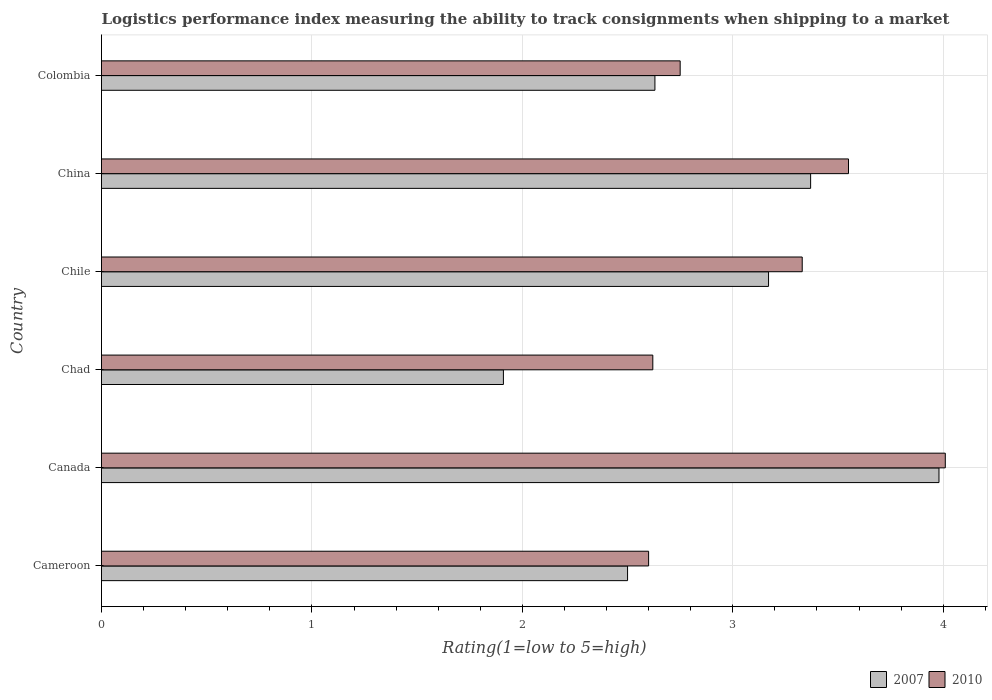How many groups of bars are there?
Your response must be concise. 6. Are the number of bars per tick equal to the number of legend labels?
Give a very brief answer. Yes. How many bars are there on the 5th tick from the top?
Offer a very short reply. 2. What is the label of the 6th group of bars from the top?
Provide a short and direct response. Cameroon. In how many cases, is the number of bars for a given country not equal to the number of legend labels?
Give a very brief answer. 0. What is the Logistic performance index in 2007 in Canada?
Keep it short and to the point. 3.98. Across all countries, what is the maximum Logistic performance index in 2007?
Offer a very short reply. 3.98. Across all countries, what is the minimum Logistic performance index in 2007?
Your answer should be very brief. 1.91. In which country was the Logistic performance index in 2007 maximum?
Provide a succinct answer. Canada. In which country was the Logistic performance index in 2007 minimum?
Ensure brevity in your answer.  Chad. What is the total Logistic performance index in 2007 in the graph?
Your answer should be compact. 17.56. What is the difference between the Logistic performance index in 2007 in Cameroon and that in Colombia?
Provide a succinct answer. -0.13. What is the difference between the Logistic performance index in 2010 in Chile and the Logistic performance index in 2007 in Colombia?
Your answer should be compact. 0.7. What is the average Logistic performance index in 2010 per country?
Offer a terse response. 3.14. What is the difference between the Logistic performance index in 2010 and Logistic performance index in 2007 in Chile?
Your answer should be compact. 0.16. In how many countries, is the Logistic performance index in 2007 greater than 2.8 ?
Offer a terse response. 3. What is the ratio of the Logistic performance index in 2010 in Cameroon to that in Chile?
Offer a terse response. 0.78. Is the Logistic performance index in 2010 in Cameroon less than that in Canada?
Give a very brief answer. Yes. What is the difference between the highest and the second highest Logistic performance index in 2010?
Provide a short and direct response. 0.46. What is the difference between the highest and the lowest Logistic performance index in 2010?
Offer a very short reply. 1.41. In how many countries, is the Logistic performance index in 2007 greater than the average Logistic performance index in 2007 taken over all countries?
Your answer should be very brief. 3. Are all the bars in the graph horizontal?
Provide a short and direct response. Yes. How many countries are there in the graph?
Keep it short and to the point. 6. Does the graph contain any zero values?
Your answer should be compact. No. What is the title of the graph?
Provide a short and direct response. Logistics performance index measuring the ability to track consignments when shipping to a market. Does "1977" appear as one of the legend labels in the graph?
Your answer should be compact. No. What is the label or title of the X-axis?
Keep it short and to the point. Rating(1=low to 5=high). What is the label or title of the Y-axis?
Ensure brevity in your answer.  Country. What is the Rating(1=low to 5=high) of 2007 in Cameroon?
Provide a short and direct response. 2.5. What is the Rating(1=low to 5=high) in 2007 in Canada?
Your answer should be compact. 3.98. What is the Rating(1=low to 5=high) in 2010 in Canada?
Provide a succinct answer. 4.01. What is the Rating(1=low to 5=high) of 2007 in Chad?
Provide a succinct answer. 1.91. What is the Rating(1=low to 5=high) of 2010 in Chad?
Offer a terse response. 2.62. What is the Rating(1=low to 5=high) of 2007 in Chile?
Your answer should be compact. 3.17. What is the Rating(1=low to 5=high) of 2010 in Chile?
Offer a very short reply. 3.33. What is the Rating(1=low to 5=high) of 2007 in China?
Ensure brevity in your answer.  3.37. What is the Rating(1=low to 5=high) of 2010 in China?
Your answer should be compact. 3.55. What is the Rating(1=low to 5=high) of 2007 in Colombia?
Make the answer very short. 2.63. What is the Rating(1=low to 5=high) in 2010 in Colombia?
Offer a terse response. 2.75. Across all countries, what is the maximum Rating(1=low to 5=high) in 2007?
Offer a very short reply. 3.98. Across all countries, what is the maximum Rating(1=low to 5=high) of 2010?
Offer a very short reply. 4.01. Across all countries, what is the minimum Rating(1=low to 5=high) of 2007?
Your answer should be very brief. 1.91. What is the total Rating(1=low to 5=high) in 2007 in the graph?
Keep it short and to the point. 17.56. What is the total Rating(1=low to 5=high) of 2010 in the graph?
Keep it short and to the point. 18.86. What is the difference between the Rating(1=low to 5=high) of 2007 in Cameroon and that in Canada?
Offer a terse response. -1.48. What is the difference between the Rating(1=low to 5=high) of 2010 in Cameroon and that in Canada?
Keep it short and to the point. -1.41. What is the difference between the Rating(1=low to 5=high) of 2007 in Cameroon and that in Chad?
Provide a short and direct response. 0.59. What is the difference between the Rating(1=low to 5=high) of 2010 in Cameroon and that in Chad?
Give a very brief answer. -0.02. What is the difference between the Rating(1=low to 5=high) in 2007 in Cameroon and that in Chile?
Keep it short and to the point. -0.67. What is the difference between the Rating(1=low to 5=high) in 2010 in Cameroon and that in Chile?
Offer a very short reply. -0.73. What is the difference between the Rating(1=low to 5=high) in 2007 in Cameroon and that in China?
Make the answer very short. -0.87. What is the difference between the Rating(1=low to 5=high) in 2010 in Cameroon and that in China?
Your answer should be compact. -0.95. What is the difference between the Rating(1=low to 5=high) of 2007 in Cameroon and that in Colombia?
Offer a terse response. -0.13. What is the difference between the Rating(1=low to 5=high) of 2010 in Cameroon and that in Colombia?
Make the answer very short. -0.15. What is the difference between the Rating(1=low to 5=high) in 2007 in Canada and that in Chad?
Keep it short and to the point. 2.07. What is the difference between the Rating(1=low to 5=high) of 2010 in Canada and that in Chad?
Offer a very short reply. 1.39. What is the difference between the Rating(1=low to 5=high) in 2007 in Canada and that in Chile?
Give a very brief answer. 0.81. What is the difference between the Rating(1=low to 5=high) in 2010 in Canada and that in Chile?
Ensure brevity in your answer.  0.68. What is the difference between the Rating(1=low to 5=high) of 2007 in Canada and that in China?
Keep it short and to the point. 0.61. What is the difference between the Rating(1=low to 5=high) in 2010 in Canada and that in China?
Give a very brief answer. 0.46. What is the difference between the Rating(1=low to 5=high) of 2007 in Canada and that in Colombia?
Keep it short and to the point. 1.35. What is the difference between the Rating(1=low to 5=high) of 2010 in Canada and that in Colombia?
Provide a succinct answer. 1.26. What is the difference between the Rating(1=low to 5=high) of 2007 in Chad and that in Chile?
Your answer should be very brief. -1.26. What is the difference between the Rating(1=low to 5=high) of 2010 in Chad and that in Chile?
Make the answer very short. -0.71. What is the difference between the Rating(1=low to 5=high) of 2007 in Chad and that in China?
Provide a short and direct response. -1.46. What is the difference between the Rating(1=low to 5=high) of 2010 in Chad and that in China?
Keep it short and to the point. -0.93. What is the difference between the Rating(1=low to 5=high) of 2007 in Chad and that in Colombia?
Ensure brevity in your answer.  -0.72. What is the difference between the Rating(1=low to 5=high) in 2010 in Chad and that in Colombia?
Your answer should be compact. -0.13. What is the difference between the Rating(1=low to 5=high) of 2007 in Chile and that in China?
Offer a very short reply. -0.2. What is the difference between the Rating(1=low to 5=high) of 2010 in Chile and that in China?
Your answer should be compact. -0.22. What is the difference between the Rating(1=low to 5=high) in 2007 in Chile and that in Colombia?
Give a very brief answer. 0.54. What is the difference between the Rating(1=low to 5=high) in 2010 in Chile and that in Colombia?
Provide a succinct answer. 0.58. What is the difference between the Rating(1=low to 5=high) of 2007 in China and that in Colombia?
Your response must be concise. 0.74. What is the difference between the Rating(1=low to 5=high) in 2007 in Cameroon and the Rating(1=low to 5=high) in 2010 in Canada?
Provide a succinct answer. -1.51. What is the difference between the Rating(1=low to 5=high) in 2007 in Cameroon and the Rating(1=low to 5=high) in 2010 in Chad?
Provide a succinct answer. -0.12. What is the difference between the Rating(1=low to 5=high) of 2007 in Cameroon and the Rating(1=low to 5=high) of 2010 in Chile?
Offer a terse response. -0.83. What is the difference between the Rating(1=low to 5=high) in 2007 in Cameroon and the Rating(1=low to 5=high) in 2010 in China?
Your answer should be compact. -1.05. What is the difference between the Rating(1=low to 5=high) in 2007 in Canada and the Rating(1=low to 5=high) in 2010 in Chad?
Your answer should be very brief. 1.36. What is the difference between the Rating(1=low to 5=high) of 2007 in Canada and the Rating(1=low to 5=high) of 2010 in Chile?
Give a very brief answer. 0.65. What is the difference between the Rating(1=low to 5=high) in 2007 in Canada and the Rating(1=low to 5=high) in 2010 in China?
Ensure brevity in your answer.  0.43. What is the difference between the Rating(1=low to 5=high) in 2007 in Canada and the Rating(1=low to 5=high) in 2010 in Colombia?
Your answer should be very brief. 1.23. What is the difference between the Rating(1=low to 5=high) of 2007 in Chad and the Rating(1=low to 5=high) of 2010 in Chile?
Provide a short and direct response. -1.42. What is the difference between the Rating(1=low to 5=high) of 2007 in Chad and the Rating(1=low to 5=high) of 2010 in China?
Make the answer very short. -1.64. What is the difference between the Rating(1=low to 5=high) in 2007 in Chad and the Rating(1=low to 5=high) in 2010 in Colombia?
Your answer should be compact. -0.84. What is the difference between the Rating(1=low to 5=high) of 2007 in Chile and the Rating(1=low to 5=high) of 2010 in China?
Provide a short and direct response. -0.38. What is the difference between the Rating(1=low to 5=high) in 2007 in Chile and the Rating(1=low to 5=high) in 2010 in Colombia?
Your response must be concise. 0.42. What is the difference between the Rating(1=low to 5=high) of 2007 in China and the Rating(1=low to 5=high) of 2010 in Colombia?
Your response must be concise. 0.62. What is the average Rating(1=low to 5=high) in 2007 per country?
Give a very brief answer. 2.93. What is the average Rating(1=low to 5=high) of 2010 per country?
Keep it short and to the point. 3.14. What is the difference between the Rating(1=low to 5=high) in 2007 and Rating(1=low to 5=high) in 2010 in Canada?
Provide a succinct answer. -0.03. What is the difference between the Rating(1=low to 5=high) of 2007 and Rating(1=low to 5=high) of 2010 in Chad?
Your answer should be compact. -0.71. What is the difference between the Rating(1=low to 5=high) of 2007 and Rating(1=low to 5=high) of 2010 in Chile?
Offer a terse response. -0.16. What is the difference between the Rating(1=low to 5=high) in 2007 and Rating(1=low to 5=high) in 2010 in China?
Your answer should be compact. -0.18. What is the difference between the Rating(1=low to 5=high) in 2007 and Rating(1=low to 5=high) in 2010 in Colombia?
Your answer should be compact. -0.12. What is the ratio of the Rating(1=low to 5=high) of 2007 in Cameroon to that in Canada?
Your response must be concise. 0.63. What is the ratio of the Rating(1=low to 5=high) of 2010 in Cameroon to that in Canada?
Offer a very short reply. 0.65. What is the ratio of the Rating(1=low to 5=high) in 2007 in Cameroon to that in Chad?
Make the answer very short. 1.31. What is the ratio of the Rating(1=low to 5=high) of 2007 in Cameroon to that in Chile?
Your answer should be very brief. 0.79. What is the ratio of the Rating(1=low to 5=high) of 2010 in Cameroon to that in Chile?
Provide a succinct answer. 0.78. What is the ratio of the Rating(1=low to 5=high) in 2007 in Cameroon to that in China?
Give a very brief answer. 0.74. What is the ratio of the Rating(1=low to 5=high) in 2010 in Cameroon to that in China?
Offer a terse response. 0.73. What is the ratio of the Rating(1=low to 5=high) of 2007 in Cameroon to that in Colombia?
Your answer should be compact. 0.95. What is the ratio of the Rating(1=low to 5=high) in 2010 in Cameroon to that in Colombia?
Your answer should be very brief. 0.95. What is the ratio of the Rating(1=low to 5=high) in 2007 in Canada to that in Chad?
Make the answer very short. 2.08. What is the ratio of the Rating(1=low to 5=high) of 2010 in Canada to that in Chad?
Ensure brevity in your answer.  1.53. What is the ratio of the Rating(1=low to 5=high) in 2007 in Canada to that in Chile?
Your answer should be very brief. 1.26. What is the ratio of the Rating(1=low to 5=high) in 2010 in Canada to that in Chile?
Your answer should be compact. 1.2. What is the ratio of the Rating(1=low to 5=high) of 2007 in Canada to that in China?
Make the answer very short. 1.18. What is the ratio of the Rating(1=low to 5=high) in 2010 in Canada to that in China?
Provide a short and direct response. 1.13. What is the ratio of the Rating(1=low to 5=high) of 2007 in Canada to that in Colombia?
Give a very brief answer. 1.51. What is the ratio of the Rating(1=low to 5=high) in 2010 in Canada to that in Colombia?
Your answer should be compact. 1.46. What is the ratio of the Rating(1=low to 5=high) in 2007 in Chad to that in Chile?
Your answer should be compact. 0.6. What is the ratio of the Rating(1=low to 5=high) in 2010 in Chad to that in Chile?
Your answer should be compact. 0.79. What is the ratio of the Rating(1=low to 5=high) of 2007 in Chad to that in China?
Provide a succinct answer. 0.57. What is the ratio of the Rating(1=low to 5=high) in 2010 in Chad to that in China?
Your response must be concise. 0.74. What is the ratio of the Rating(1=low to 5=high) in 2007 in Chad to that in Colombia?
Your answer should be very brief. 0.73. What is the ratio of the Rating(1=low to 5=high) in 2010 in Chad to that in Colombia?
Your answer should be very brief. 0.95. What is the ratio of the Rating(1=low to 5=high) of 2007 in Chile to that in China?
Keep it short and to the point. 0.94. What is the ratio of the Rating(1=low to 5=high) in 2010 in Chile to that in China?
Give a very brief answer. 0.94. What is the ratio of the Rating(1=low to 5=high) of 2007 in Chile to that in Colombia?
Keep it short and to the point. 1.21. What is the ratio of the Rating(1=low to 5=high) of 2010 in Chile to that in Colombia?
Give a very brief answer. 1.21. What is the ratio of the Rating(1=low to 5=high) of 2007 in China to that in Colombia?
Ensure brevity in your answer.  1.28. What is the ratio of the Rating(1=low to 5=high) of 2010 in China to that in Colombia?
Your answer should be compact. 1.29. What is the difference between the highest and the second highest Rating(1=low to 5=high) in 2007?
Your answer should be compact. 0.61. What is the difference between the highest and the second highest Rating(1=low to 5=high) in 2010?
Provide a short and direct response. 0.46. What is the difference between the highest and the lowest Rating(1=low to 5=high) of 2007?
Offer a terse response. 2.07. What is the difference between the highest and the lowest Rating(1=low to 5=high) in 2010?
Offer a very short reply. 1.41. 